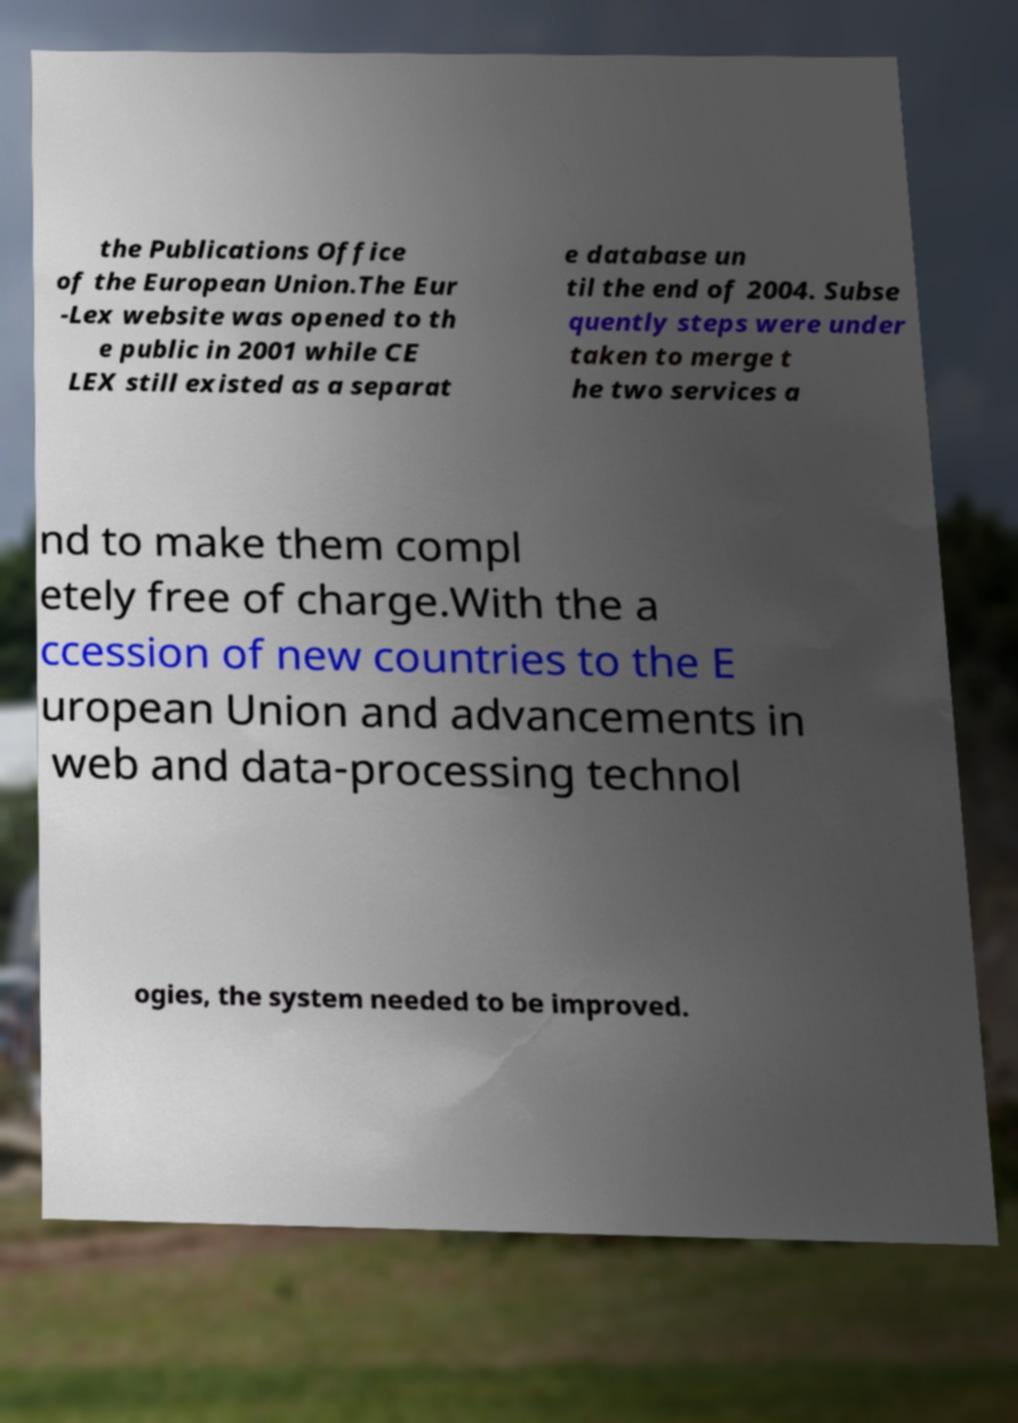Can you read and provide the text displayed in the image?This photo seems to have some interesting text. Can you extract and type it out for me? the Publications Office of the European Union.The Eur -Lex website was opened to th e public in 2001 while CE LEX still existed as a separat e database un til the end of 2004. Subse quently steps were under taken to merge t he two services a nd to make them compl etely free of charge.With the a ccession of new countries to the E uropean Union and advancements in web and data-processing technol ogies, the system needed to be improved. 